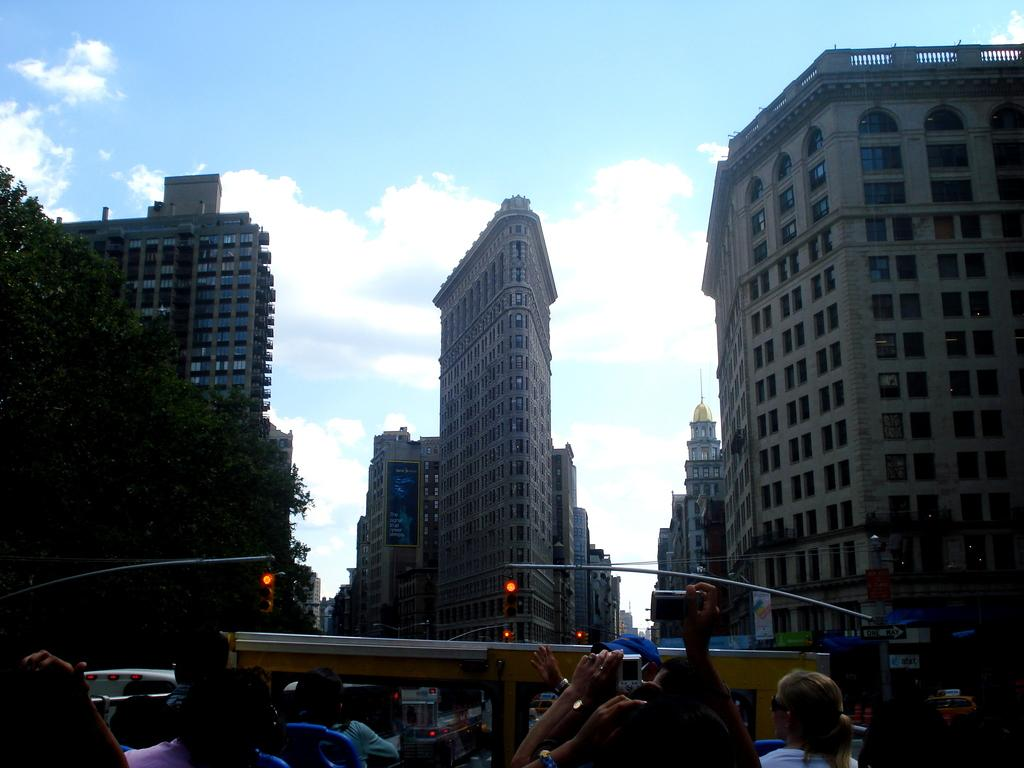What type of structures can be seen in the image? There are buildings in the image. Who or what else is present in the image? There is a group of people in the image. What can be used to control traffic in the image? Signal lights are present in the image. What type of vegetation can be seen in the image? There are trees in the image. What is visible in the background of the image? The sky is visible in the background of the image. Can you tell me how many matches the judge is holding in the image? There is no judge or matches present in the image. What type of monkey can be seen climbing the trees in the image? There are no monkeys present in the image; it features buildings, a group of people, signal lights, trees, and the sky. 